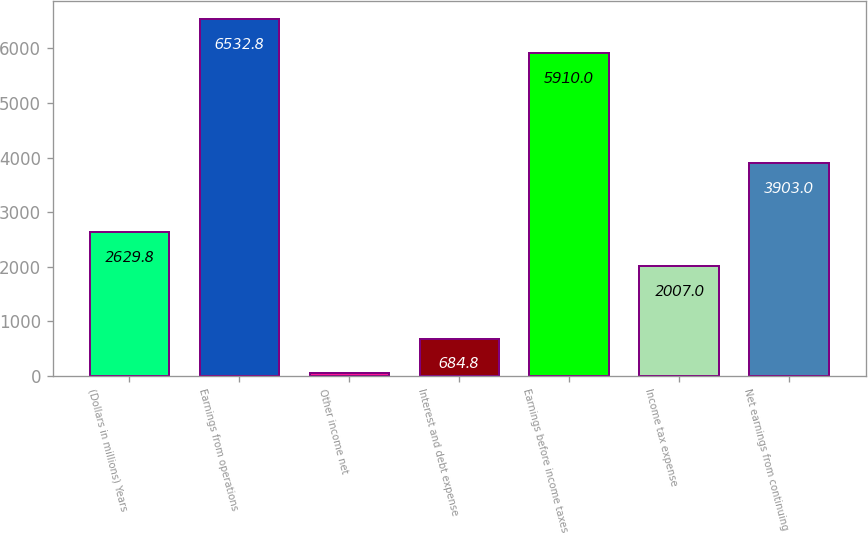<chart> <loc_0><loc_0><loc_500><loc_500><bar_chart><fcel>(Dollars in millions) Years<fcel>Earnings from operations<fcel>Other income net<fcel>Interest and debt expense<fcel>Earnings before income taxes<fcel>Income tax expense<fcel>Net earnings from continuing<nl><fcel>2629.8<fcel>6532.8<fcel>62<fcel>684.8<fcel>5910<fcel>2007<fcel>3903<nl></chart> 